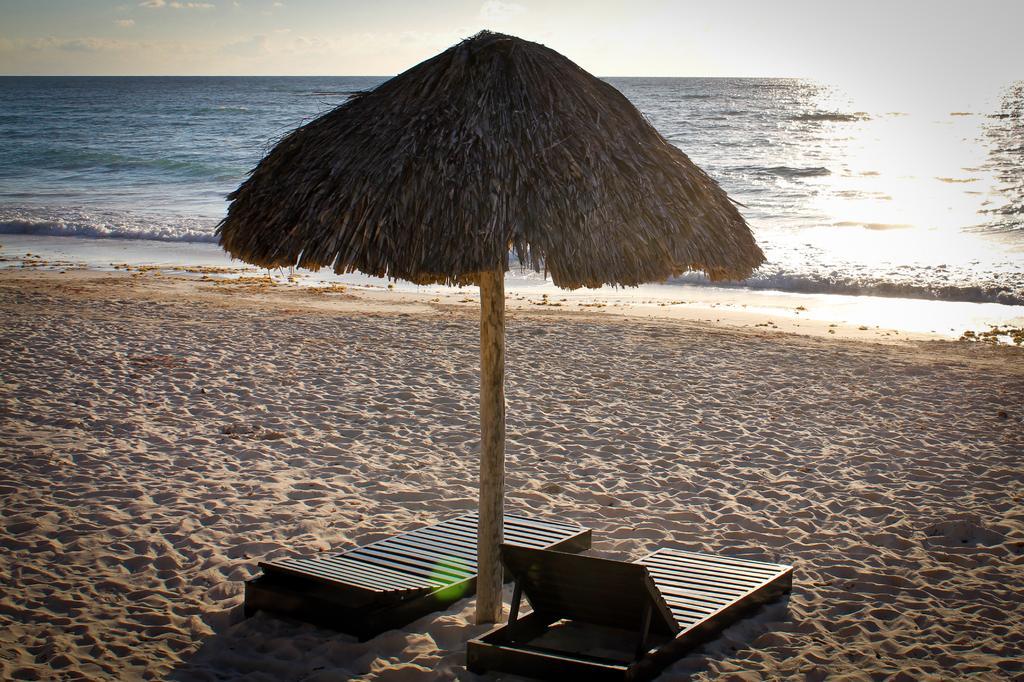Could you give a brief overview of what you see in this image? In this picture it looks like a hut and there are chairs in the foreground. At the back there is water. At the top there is sky and there are clouds. At the bottom there is sand. 